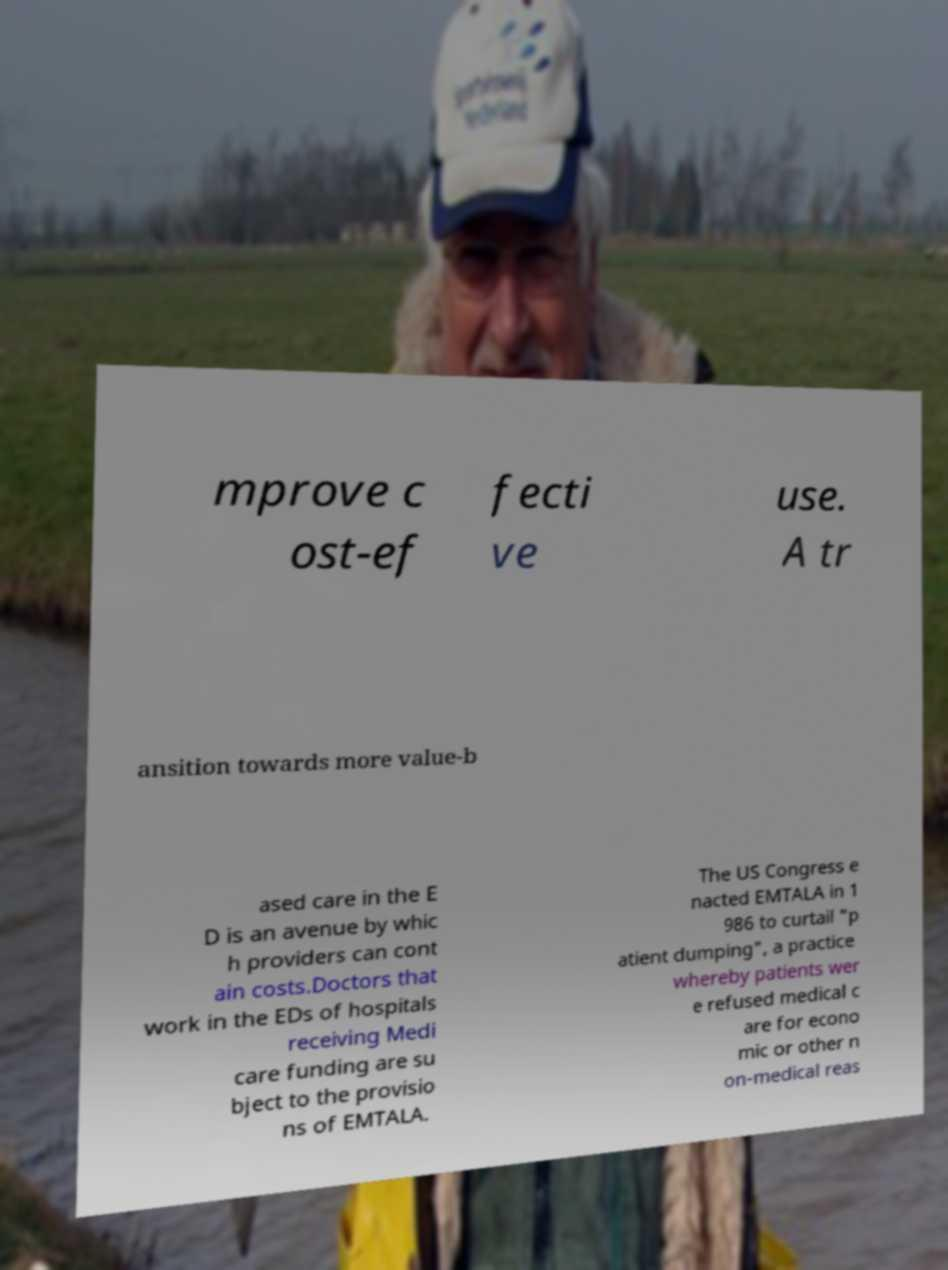Can you read and provide the text displayed in the image?This photo seems to have some interesting text. Can you extract and type it out for me? mprove c ost-ef fecti ve use. A tr ansition towards more value-b ased care in the E D is an avenue by whic h providers can cont ain costs.Doctors that work in the EDs of hospitals receiving Medi care funding are su bject to the provisio ns of EMTALA. The US Congress e nacted EMTALA in 1 986 to curtail "p atient dumping", a practice whereby patients wer e refused medical c are for econo mic or other n on-medical reas 